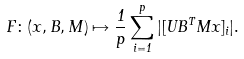Convert formula to latex. <formula><loc_0><loc_0><loc_500><loc_500>F \colon ( x , B , M ) \mapsto \frac { 1 } { p } \sum _ { i = 1 } ^ { p } | [ U B ^ { T } M x ] _ { i } | .</formula> 